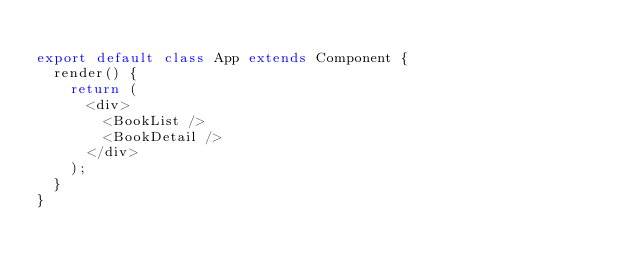Convert code to text. <code><loc_0><loc_0><loc_500><loc_500><_JavaScript_>
export default class App extends Component {
  render() {
    return (
      <div>
      	<BookList />
      	<BookDetail />
      </div>
    );
  }
}
</code> 